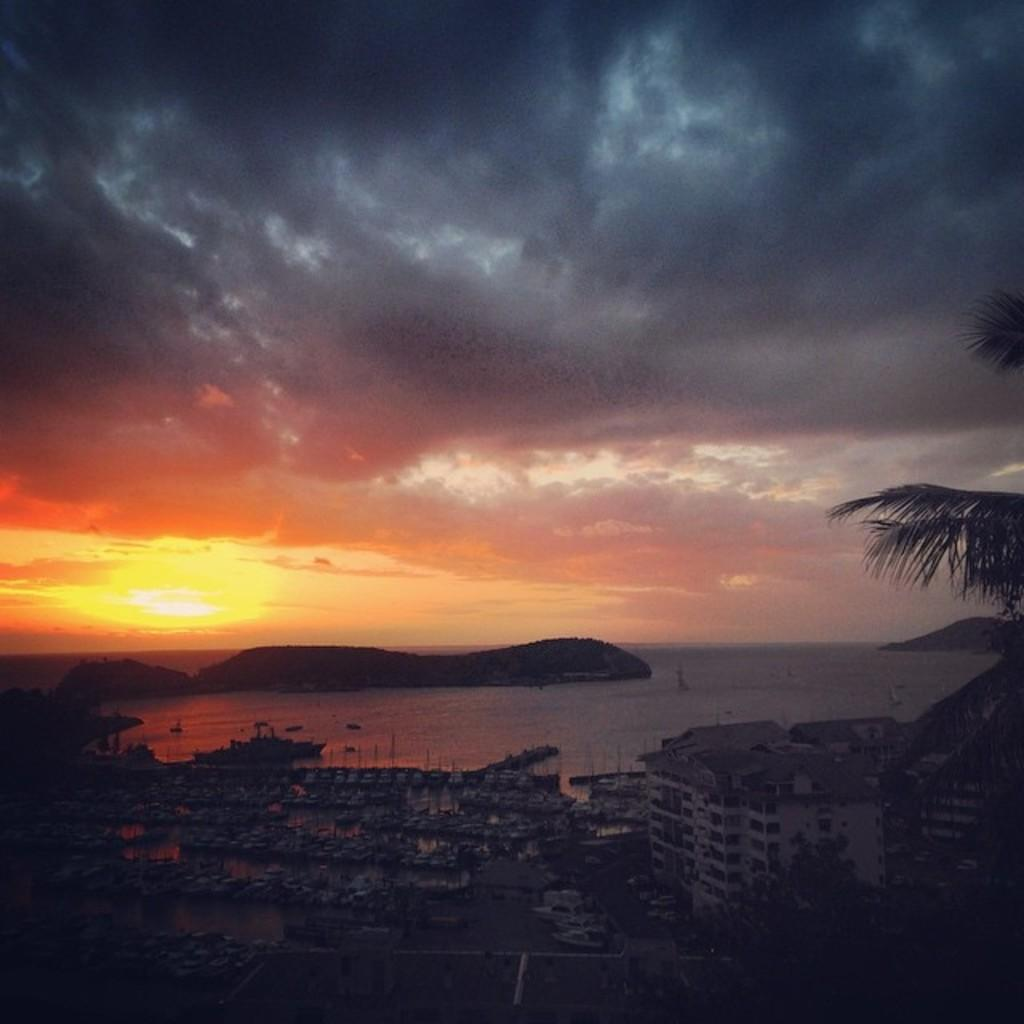What type of structure is present in the image? There is a building in the image. What is located near the building? There is water in the image, and a boat is in the water. What is the weather like in the image? The sky is visible in the image, and there are clouds and the sun visible, suggesting a partly cloudy day. What else can be seen in the image? There is a tree in the image. How would you describe the overall lighting in the image? The image appears to be slightly dark. What type of pig can be seen playing with an iron in the image? There is no pig or iron present in the image. How does the cat interact with the tree in the image? There is no cat present in the image; only a tree is visible. 